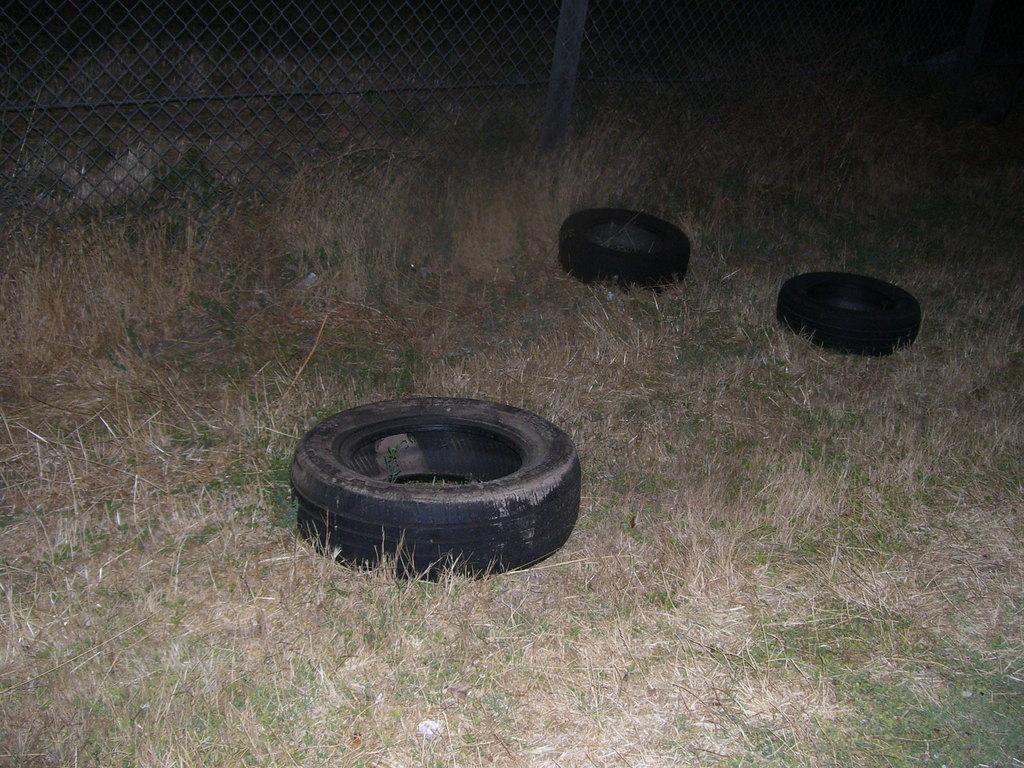What objects are in the foreground of the picture? There are tyres and grass in the foreground of the picture. Can you describe the type of grass in the foreground? The grass in the foreground is dry. What can be seen in the background of the picture? There is fencing and grass outside the fencing in the background of the picture. What type of ornament is hanging from the tyres in the image? There is no ornament hanging from the tyres in the image. How does the brain react to the dry grass in the foreground of the image? The image does not depict a brain, so it is not possible to determine its reaction to the dry grass. 